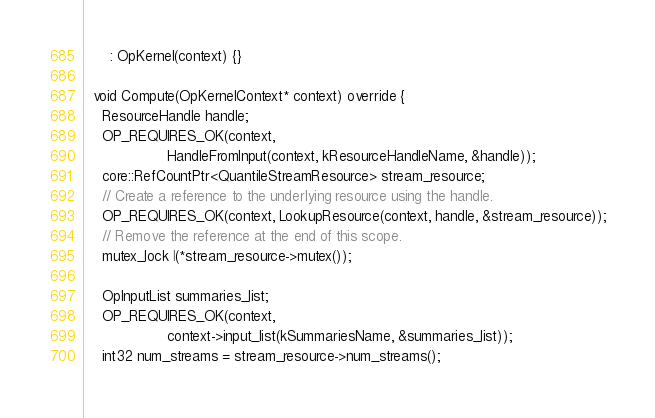<code> <loc_0><loc_0><loc_500><loc_500><_C++_>      : OpKernel(context) {}

  void Compute(OpKernelContext* context) override {
    ResourceHandle handle;
    OP_REQUIRES_OK(context,
                   HandleFromInput(context, kResourceHandleName, &handle));
    core::RefCountPtr<QuantileStreamResource> stream_resource;
    // Create a reference to the underlying resource using the handle.
    OP_REQUIRES_OK(context, LookupResource(context, handle, &stream_resource));
    // Remove the reference at the end of this scope.
    mutex_lock l(*stream_resource->mutex());

    OpInputList summaries_list;
    OP_REQUIRES_OK(context,
                   context->input_list(kSummariesName, &summaries_list));
    int32 num_streams = stream_resource->num_streams();</code> 